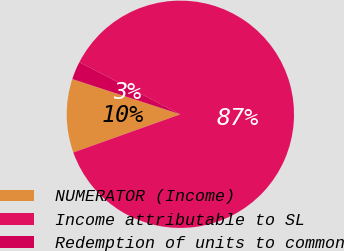Convert chart. <chart><loc_0><loc_0><loc_500><loc_500><pie_chart><fcel>NUMERATOR (Income)<fcel>Income attributable to SL<fcel>Redemption of units to common<nl><fcel>10.47%<fcel>86.97%<fcel>2.56%<nl></chart> 